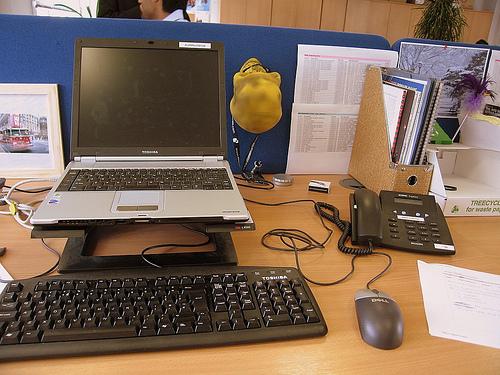Which item has the same name as the creature that ran up the clock in the nursery rhyme?
Give a very brief answer. Mouse. Why is the computer so high?
Write a very short answer. On stand. Is there more than one computer in the photo?
Write a very short answer. No. What is purple?
Answer briefly. Feather. How many women?
Short answer required. 0. Is the computer on?
Short answer required. No. 